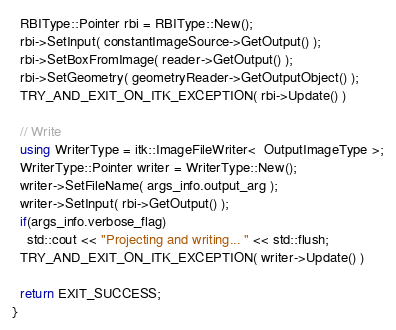Convert code to text. <code><loc_0><loc_0><loc_500><loc_500><_C++_>  RBIType::Pointer rbi = RBIType::New();
  rbi->SetInput( constantImageSource->GetOutput() );
  rbi->SetBoxFromImage( reader->GetOutput() );
  rbi->SetGeometry( geometryReader->GetOutputObject() );
  TRY_AND_EXIT_ON_ITK_EXCEPTION( rbi->Update() )

  // Write
  using WriterType = itk::ImageFileWriter<  OutputImageType >;
  WriterType::Pointer writer = WriterType::New();
  writer->SetFileName( args_info.output_arg );
  writer->SetInput( rbi->GetOutput() );
  if(args_info.verbose_flag)
    std::cout << "Projecting and writing... " << std::flush;
  TRY_AND_EXIT_ON_ITK_EXCEPTION( writer->Update() )

  return EXIT_SUCCESS;
}
</code> 